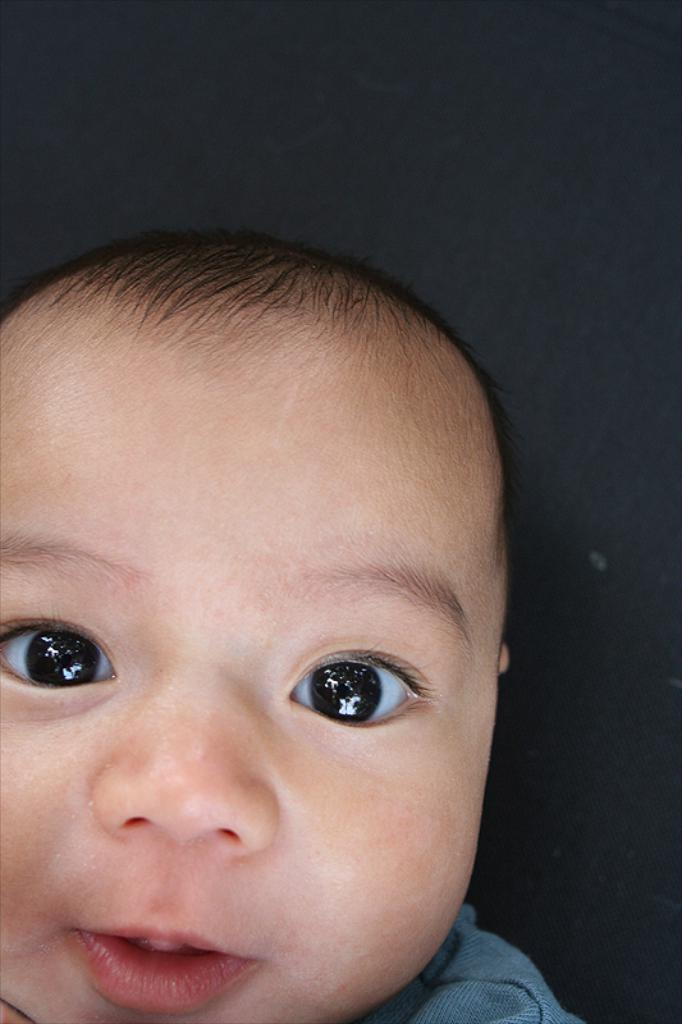What is the main subject of the image? The main subject of the image is a baby. What can be seen in the background of the image? The background of the image is black. Can you tell me how many kittens are running on the baby's toes in the image? There are no kittens or running activity present in the image. 